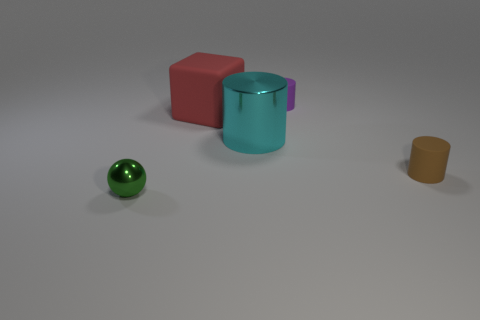Are there any other things that are the same shape as the big shiny thing?
Offer a terse response. Yes. What shape is the tiny thing that is to the right of the small cylinder behind the small brown thing?
Make the answer very short. Cylinder. There is a small purple object that is made of the same material as the tiny brown cylinder; what shape is it?
Offer a very short reply. Cylinder. There is a shiny thing that is in front of the tiny rubber thing in front of the large cyan shiny cylinder; what size is it?
Your answer should be very brief. Small. What is the shape of the purple rubber thing?
Provide a succinct answer. Cylinder. How many large objects are either rubber cylinders or balls?
Offer a very short reply. 0. The other rubber object that is the same shape as the small purple matte object is what size?
Provide a succinct answer. Small. How many things are in front of the large rubber cube and on the right side of the sphere?
Your response must be concise. 2. Do the tiny brown rubber thing and the cyan shiny thing that is in front of the purple cylinder have the same shape?
Your answer should be very brief. Yes. Is the number of brown rubber objects that are in front of the purple thing greater than the number of big green rubber blocks?
Provide a short and direct response. Yes. 